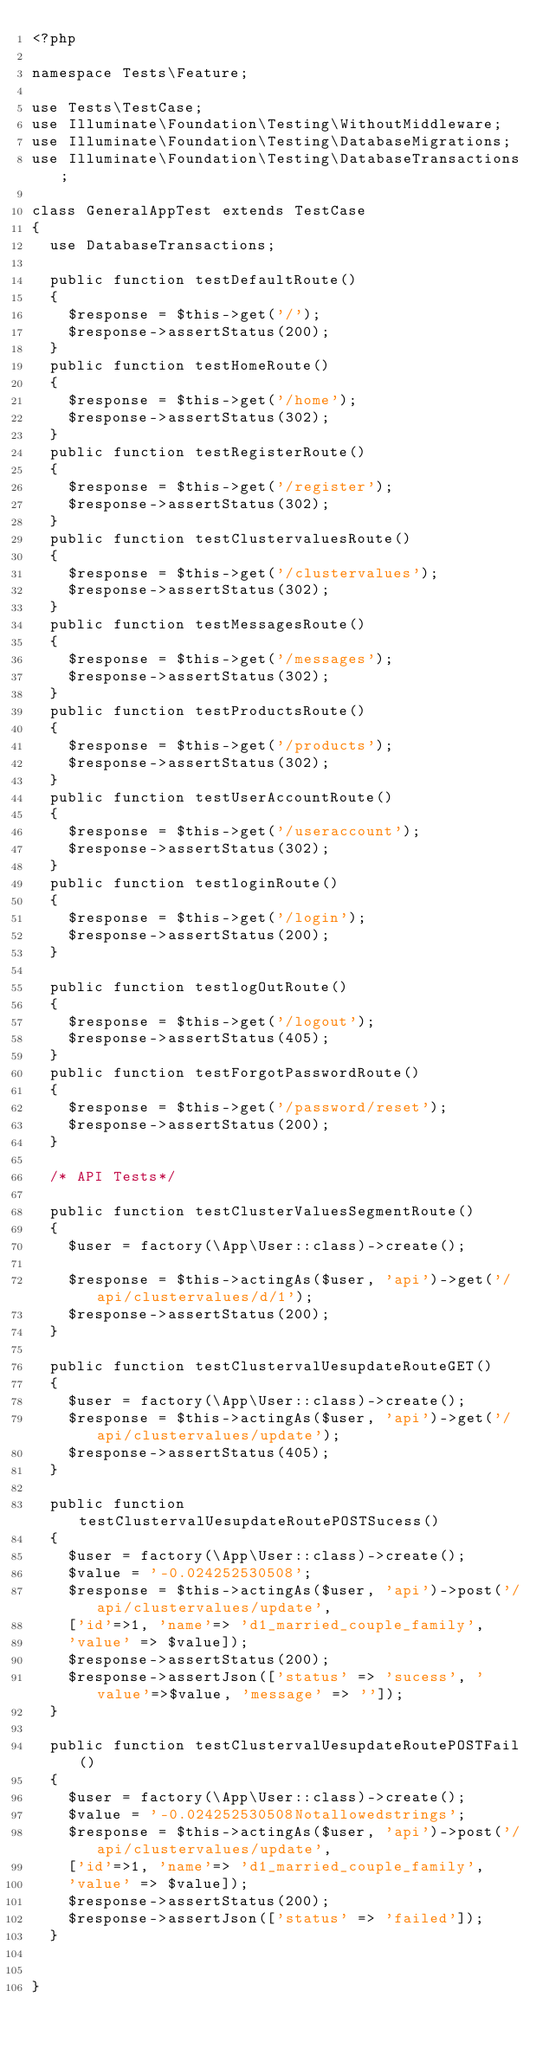<code> <loc_0><loc_0><loc_500><loc_500><_PHP_><?php

namespace Tests\Feature;

use Tests\TestCase;
use Illuminate\Foundation\Testing\WithoutMiddleware;
use Illuminate\Foundation\Testing\DatabaseMigrations;
use Illuminate\Foundation\Testing\DatabaseTransactions;

class GeneralAppTest extends TestCase
{
  use DatabaseTransactions;

  public function testDefaultRoute()
  {
    $response = $this->get('/');
    $response->assertStatus(200);
  }
  public function testHomeRoute()
  {
    $response = $this->get('/home');
    $response->assertStatus(302);
  }
  public function testRegisterRoute()
  {
    $response = $this->get('/register');
    $response->assertStatus(302);
  }
  public function testClustervaluesRoute()
  {
    $response = $this->get('/clustervalues');
    $response->assertStatus(302);
  }
  public function testMessagesRoute()
  {
    $response = $this->get('/messages');
    $response->assertStatus(302);
  }
  public function testProductsRoute()
  {
    $response = $this->get('/products');
    $response->assertStatus(302);
  }
  public function testUserAccountRoute()
  {
    $response = $this->get('/useraccount');
    $response->assertStatus(302);
  }
  public function testloginRoute()
  {
    $response = $this->get('/login');
    $response->assertStatus(200);
  }

  public function testlogOutRoute()
  {
    $response = $this->get('/logout');
    $response->assertStatus(405);
  }
  public function testForgotPasswordRoute()
  {
    $response = $this->get('/password/reset');
    $response->assertStatus(200);
  }

  /* API Tests*/

  public function testClusterValuesSegmentRoute()
  {
    $user = factory(\App\User::class)->create();

    $response = $this->actingAs($user, 'api')->get('/api/clustervalues/d/1');
    $response->assertStatus(200);
  }

  public function testClustervalUesupdateRouteGET()
  {
    $user = factory(\App\User::class)->create();
    $response = $this->actingAs($user, 'api')->get('/api/clustervalues/update');
    $response->assertStatus(405);
  }

  public function testClustervalUesupdateRoutePOSTSucess()
  {
    $user = factory(\App\User::class)->create();
    $value = '-0.024252530508';
    $response = $this->actingAs($user, 'api')->post('/api/clustervalues/update',
    ['id'=>1, 'name'=> 'd1_married_couple_family',
    'value' => $value]);
    $response->assertStatus(200);
    $response->assertJson(['status' => 'sucess', 'value'=>$value, 'message' => '']);
  }

  public function testClustervalUesupdateRoutePOSTFail()
  {
    $user = factory(\App\User::class)->create();
    $value = '-0.024252530508Notallowedstrings';
    $response = $this->actingAs($user, 'api')->post('/api/clustervalues/update',
    ['id'=>1, 'name'=> 'd1_married_couple_family',
    'value' => $value]);
    $response->assertStatus(200);
    $response->assertJson(['status' => 'failed']);
  }


}
</code> 